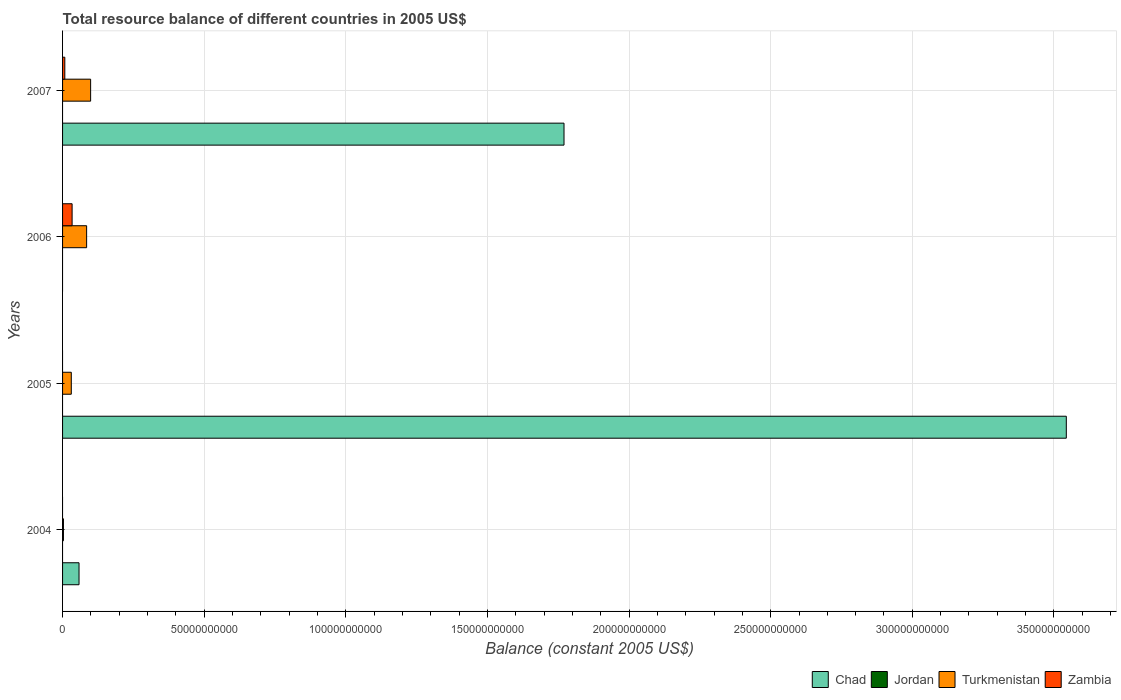Are the number of bars on each tick of the Y-axis equal?
Your response must be concise. No. How many bars are there on the 3rd tick from the top?
Provide a succinct answer. 2. How many bars are there on the 3rd tick from the bottom?
Ensure brevity in your answer.  2. What is the total resource balance in Turkmenistan in 2004?
Provide a succinct answer. 3.13e+08. Across all years, what is the maximum total resource balance in Zambia?
Ensure brevity in your answer.  3.37e+09. In which year was the total resource balance in Turkmenistan maximum?
Offer a very short reply. 2007. What is the total total resource balance in Turkmenistan in the graph?
Offer a terse response. 2.18e+1. What is the difference between the total resource balance in Chad in 2004 and that in 2007?
Offer a very short reply. -1.71e+11. What is the difference between the total resource balance in Turkmenistan in 2006 and the total resource balance in Jordan in 2007?
Your response must be concise. 8.49e+09. What is the average total resource balance in Chad per year?
Your response must be concise. 1.34e+11. In the year 2004, what is the difference between the total resource balance in Chad and total resource balance in Turkmenistan?
Keep it short and to the point. 5.50e+09. In how many years, is the total resource balance in Chad greater than 30000000000 US$?
Give a very brief answer. 2. What is the ratio of the total resource balance in Turkmenistan in 2004 to that in 2005?
Offer a terse response. 0.1. What is the difference between the highest and the second highest total resource balance in Chad?
Keep it short and to the point. 1.77e+11. What is the difference between the highest and the lowest total resource balance in Chad?
Make the answer very short. 3.54e+11. Is it the case that in every year, the sum of the total resource balance in Zambia and total resource balance in Turkmenistan is greater than the sum of total resource balance in Jordan and total resource balance in Chad?
Provide a short and direct response. No. What is the difference between two consecutive major ticks on the X-axis?
Offer a terse response. 5.00e+1. Does the graph contain grids?
Offer a terse response. Yes. Where does the legend appear in the graph?
Offer a very short reply. Bottom right. How many legend labels are there?
Your answer should be very brief. 4. What is the title of the graph?
Offer a very short reply. Total resource balance of different countries in 2005 US$. What is the label or title of the X-axis?
Provide a succinct answer. Balance (constant 2005 US$). What is the label or title of the Y-axis?
Your response must be concise. Years. What is the Balance (constant 2005 US$) in Chad in 2004?
Provide a succinct answer. 5.81e+09. What is the Balance (constant 2005 US$) in Jordan in 2004?
Make the answer very short. 0. What is the Balance (constant 2005 US$) in Turkmenistan in 2004?
Keep it short and to the point. 3.13e+08. What is the Balance (constant 2005 US$) in Zambia in 2004?
Provide a short and direct response. 0. What is the Balance (constant 2005 US$) of Chad in 2005?
Offer a terse response. 3.54e+11. What is the Balance (constant 2005 US$) of Jordan in 2005?
Provide a succinct answer. 0. What is the Balance (constant 2005 US$) of Turkmenistan in 2005?
Your response must be concise. 3.08e+09. What is the Balance (constant 2005 US$) in Zambia in 2005?
Make the answer very short. 0. What is the Balance (constant 2005 US$) of Jordan in 2006?
Provide a short and direct response. 0. What is the Balance (constant 2005 US$) of Turkmenistan in 2006?
Keep it short and to the point. 8.49e+09. What is the Balance (constant 2005 US$) of Zambia in 2006?
Provide a short and direct response. 3.37e+09. What is the Balance (constant 2005 US$) in Chad in 2007?
Offer a very short reply. 1.77e+11. What is the Balance (constant 2005 US$) of Turkmenistan in 2007?
Offer a very short reply. 9.91e+09. What is the Balance (constant 2005 US$) in Zambia in 2007?
Offer a very short reply. 7.94e+08. Across all years, what is the maximum Balance (constant 2005 US$) in Chad?
Provide a short and direct response. 3.54e+11. Across all years, what is the maximum Balance (constant 2005 US$) of Turkmenistan?
Provide a short and direct response. 9.91e+09. Across all years, what is the maximum Balance (constant 2005 US$) of Zambia?
Make the answer very short. 3.37e+09. Across all years, what is the minimum Balance (constant 2005 US$) of Chad?
Your answer should be compact. 0. Across all years, what is the minimum Balance (constant 2005 US$) in Turkmenistan?
Provide a succinct answer. 3.13e+08. Across all years, what is the minimum Balance (constant 2005 US$) of Zambia?
Your response must be concise. 0. What is the total Balance (constant 2005 US$) of Chad in the graph?
Ensure brevity in your answer.  5.37e+11. What is the total Balance (constant 2005 US$) in Jordan in the graph?
Keep it short and to the point. 0. What is the total Balance (constant 2005 US$) of Turkmenistan in the graph?
Provide a short and direct response. 2.18e+1. What is the total Balance (constant 2005 US$) in Zambia in the graph?
Make the answer very short. 4.16e+09. What is the difference between the Balance (constant 2005 US$) of Chad in 2004 and that in 2005?
Your answer should be very brief. -3.49e+11. What is the difference between the Balance (constant 2005 US$) of Turkmenistan in 2004 and that in 2005?
Make the answer very short. -2.77e+09. What is the difference between the Balance (constant 2005 US$) in Turkmenistan in 2004 and that in 2006?
Offer a terse response. -8.18e+09. What is the difference between the Balance (constant 2005 US$) in Chad in 2004 and that in 2007?
Keep it short and to the point. -1.71e+11. What is the difference between the Balance (constant 2005 US$) in Turkmenistan in 2004 and that in 2007?
Offer a terse response. -9.59e+09. What is the difference between the Balance (constant 2005 US$) of Turkmenistan in 2005 and that in 2006?
Your response must be concise. -5.41e+09. What is the difference between the Balance (constant 2005 US$) of Chad in 2005 and that in 2007?
Give a very brief answer. 1.77e+11. What is the difference between the Balance (constant 2005 US$) of Turkmenistan in 2005 and that in 2007?
Ensure brevity in your answer.  -6.83e+09. What is the difference between the Balance (constant 2005 US$) in Turkmenistan in 2006 and that in 2007?
Provide a short and direct response. -1.41e+09. What is the difference between the Balance (constant 2005 US$) in Zambia in 2006 and that in 2007?
Provide a short and direct response. 2.57e+09. What is the difference between the Balance (constant 2005 US$) of Chad in 2004 and the Balance (constant 2005 US$) of Turkmenistan in 2005?
Your answer should be compact. 2.73e+09. What is the difference between the Balance (constant 2005 US$) in Chad in 2004 and the Balance (constant 2005 US$) in Turkmenistan in 2006?
Provide a short and direct response. -2.68e+09. What is the difference between the Balance (constant 2005 US$) in Chad in 2004 and the Balance (constant 2005 US$) in Zambia in 2006?
Provide a succinct answer. 2.44e+09. What is the difference between the Balance (constant 2005 US$) of Turkmenistan in 2004 and the Balance (constant 2005 US$) of Zambia in 2006?
Your answer should be compact. -3.06e+09. What is the difference between the Balance (constant 2005 US$) of Chad in 2004 and the Balance (constant 2005 US$) of Turkmenistan in 2007?
Your answer should be compact. -4.10e+09. What is the difference between the Balance (constant 2005 US$) of Chad in 2004 and the Balance (constant 2005 US$) of Zambia in 2007?
Offer a terse response. 5.02e+09. What is the difference between the Balance (constant 2005 US$) in Turkmenistan in 2004 and the Balance (constant 2005 US$) in Zambia in 2007?
Your response must be concise. -4.81e+08. What is the difference between the Balance (constant 2005 US$) in Chad in 2005 and the Balance (constant 2005 US$) in Turkmenistan in 2006?
Keep it short and to the point. 3.46e+11. What is the difference between the Balance (constant 2005 US$) of Chad in 2005 and the Balance (constant 2005 US$) of Zambia in 2006?
Ensure brevity in your answer.  3.51e+11. What is the difference between the Balance (constant 2005 US$) in Turkmenistan in 2005 and the Balance (constant 2005 US$) in Zambia in 2006?
Your answer should be very brief. -2.88e+08. What is the difference between the Balance (constant 2005 US$) of Chad in 2005 and the Balance (constant 2005 US$) of Turkmenistan in 2007?
Make the answer very short. 3.44e+11. What is the difference between the Balance (constant 2005 US$) in Chad in 2005 and the Balance (constant 2005 US$) in Zambia in 2007?
Provide a succinct answer. 3.54e+11. What is the difference between the Balance (constant 2005 US$) of Turkmenistan in 2005 and the Balance (constant 2005 US$) of Zambia in 2007?
Keep it short and to the point. 2.29e+09. What is the difference between the Balance (constant 2005 US$) of Turkmenistan in 2006 and the Balance (constant 2005 US$) of Zambia in 2007?
Your answer should be compact. 7.70e+09. What is the average Balance (constant 2005 US$) in Chad per year?
Offer a very short reply. 1.34e+11. What is the average Balance (constant 2005 US$) in Jordan per year?
Provide a succinct answer. 0. What is the average Balance (constant 2005 US$) in Turkmenistan per year?
Provide a succinct answer. 5.45e+09. What is the average Balance (constant 2005 US$) in Zambia per year?
Ensure brevity in your answer.  1.04e+09. In the year 2004, what is the difference between the Balance (constant 2005 US$) of Chad and Balance (constant 2005 US$) of Turkmenistan?
Give a very brief answer. 5.50e+09. In the year 2005, what is the difference between the Balance (constant 2005 US$) of Chad and Balance (constant 2005 US$) of Turkmenistan?
Offer a terse response. 3.51e+11. In the year 2006, what is the difference between the Balance (constant 2005 US$) of Turkmenistan and Balance (constant 2005 US$) of Zambia?
Your response must be concise. 5.12e+09. In the year 2007, what is the difference between the Balance (constant 2005 US$) of Chad and Balance (constant 2005 US$) of Turkmenistan?
Your response must be concise. 1.67e+11. In the year 2007, what is the difference between the Balance (constant 2005 US$) in Chad and Balance (constant 2005 US$) in Zambia?
Make the answer very short. 1.76e+11. In the year 2007, what is the difference between the Balance (constant 2005 US$) in Turkmenistan and Balance (constant 2005 US$) in Zambia?
Give a very brief answer. 9.11e+09. What is the ratio of the Balance (constant 2005 US$) of Chad in 2004 to that in 2005?
Make the answer very short. 0.02. What is the ratio of the Balance (constant 2005 US$) of Turkmenistan in 2004 to that in 2005?
Ensure brevity in your answer.  0.1. What is the ratio of the Balance (constant 2005 US$) in Turkmenistan in 2004 to that in 2006?
Offer a terse response. 0.04. What is the ratio of the Balance (constant 2005 US$) in Chad in 2004 to that in 2007?
Keep it short and to the point. 0.03. What is the ratio of the Balance (constant 2005 US$) of Turkmenistan in 2004 to that in 2007?
Keep it short and to the point. 0.03. What is the ratio of the Balance (constant 2005 US$) in Turkmenistan in 2005 to that in 2006?
Your response must be concise. 0.36. What is the ratio of the Balance (constant 2005 US$) of Chad in 2005 to that in 2007?
Provide a short and direct response. 2. What is the ratio of the Balance (constant 2005 US$) in Turkmenistan in 2005 to that in 2007?
Your answer should be compact. 0.31. What is the ratio of the Balance (constant 2005 US$) of Turkmenistan in 2006 to that in 2007?
Keep it short and to the point. 0.86. What is the ratio of the Balance (constant 2005 US$) of Zambia in 2006 to that in 2007?
Provide a short and direct response. 4.24. What is the difference between the highest and the second highest Balance (constant 2005 US$) in Chad?
Make the answer very short. 1.77e+11. What is the difference between the highest and the second highest Balance (constant 2005 US$) in Turkmenistan?
Offer a terse response. 1.41e+09. What is the difference between the highest and the lowest Balance (constant 2005 US$) in Chad?
Provide a short and direct response. 3.54e+11. What is the difference between the highest and the lowest Balance (constant 2005 US$) of Turkmenistan?
Provide a succinct answer. 9.59e+09. What is the difference between the highest and the lowest Balance (constant 2005 US$) of Zambia?
Provide a succinct answer. 3.37e+09. 